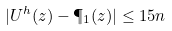<formula> <loc_0><loc_0><loc_500><loc_500>| U ^ { h } ( z ) - \P _ { 1 } ( z ) | \leq 1 5 n</formula> 